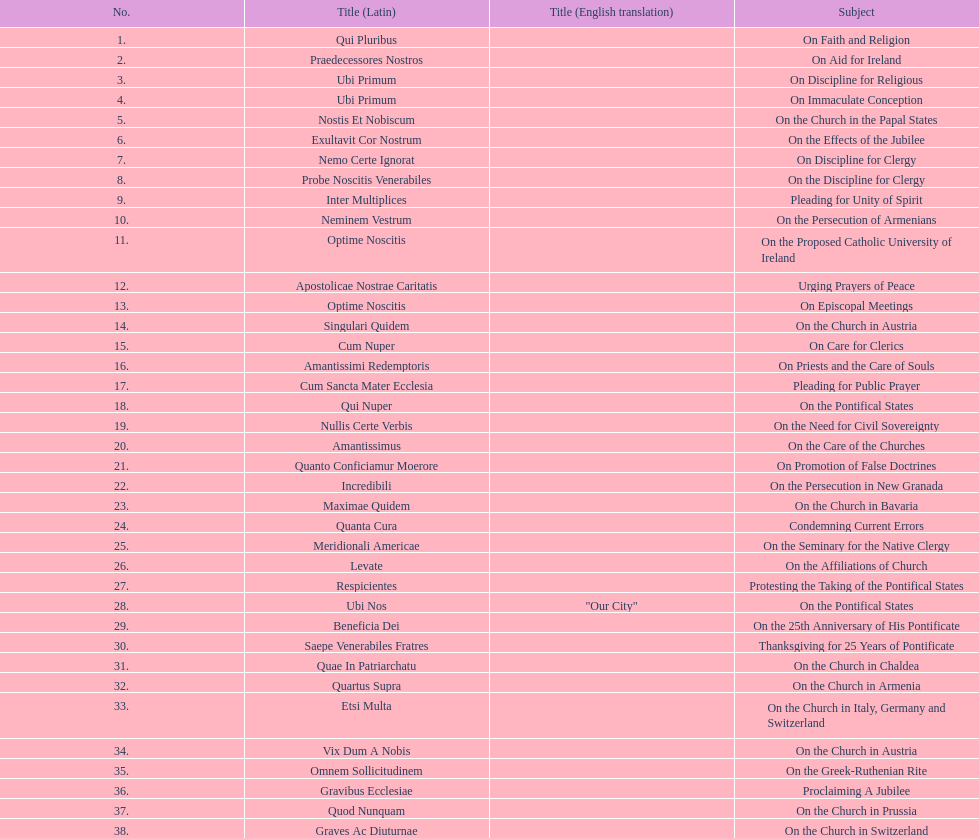How many encyclicals were issued between august 15, 1854 and october 26, 1867? 13. 